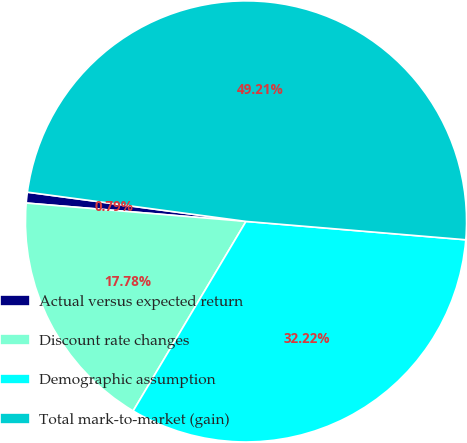<chart> <loc_0><loc_0><loc_500><loc_500><pie_chart><fcel>Actual versus expected return<fcel>Discount rate changes<fcel>Demographic assumption<fcel>Total mark-to-market (gain)<nl><fcel>0.79%<fcel>17.78%<fcel>32.22%<fcel>49.21%<nl></chart> 